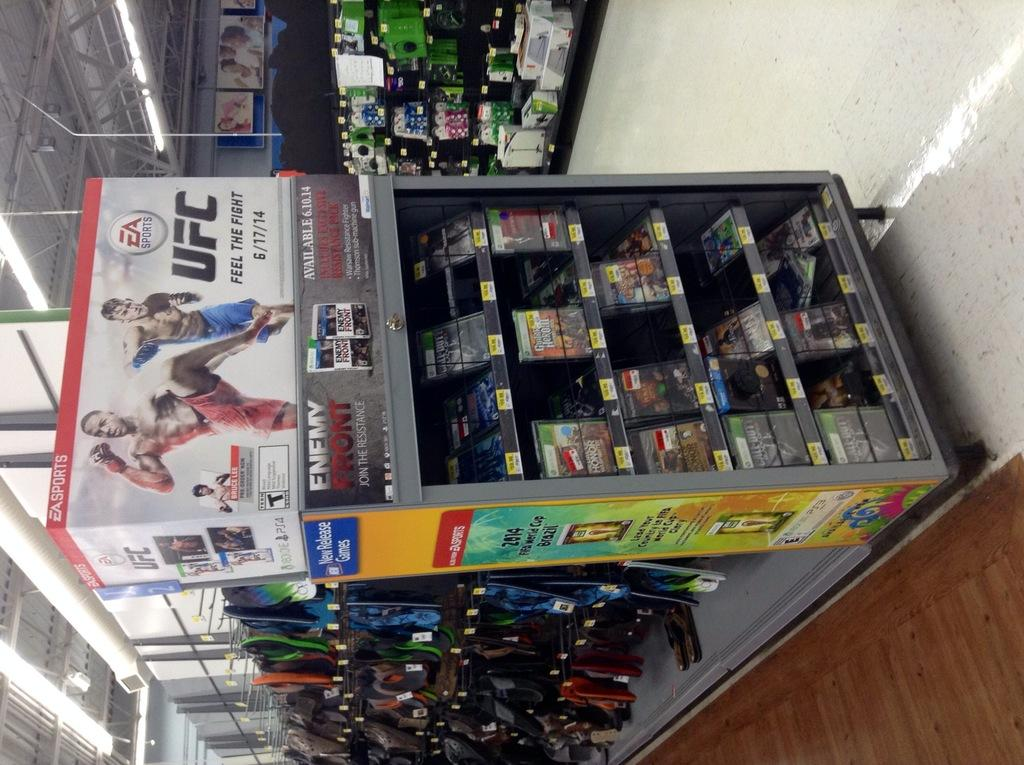<image>
Share a concise interpretation of the image provided. A box promoting an EA ultimate fighting game sits on top of a display in a store. 